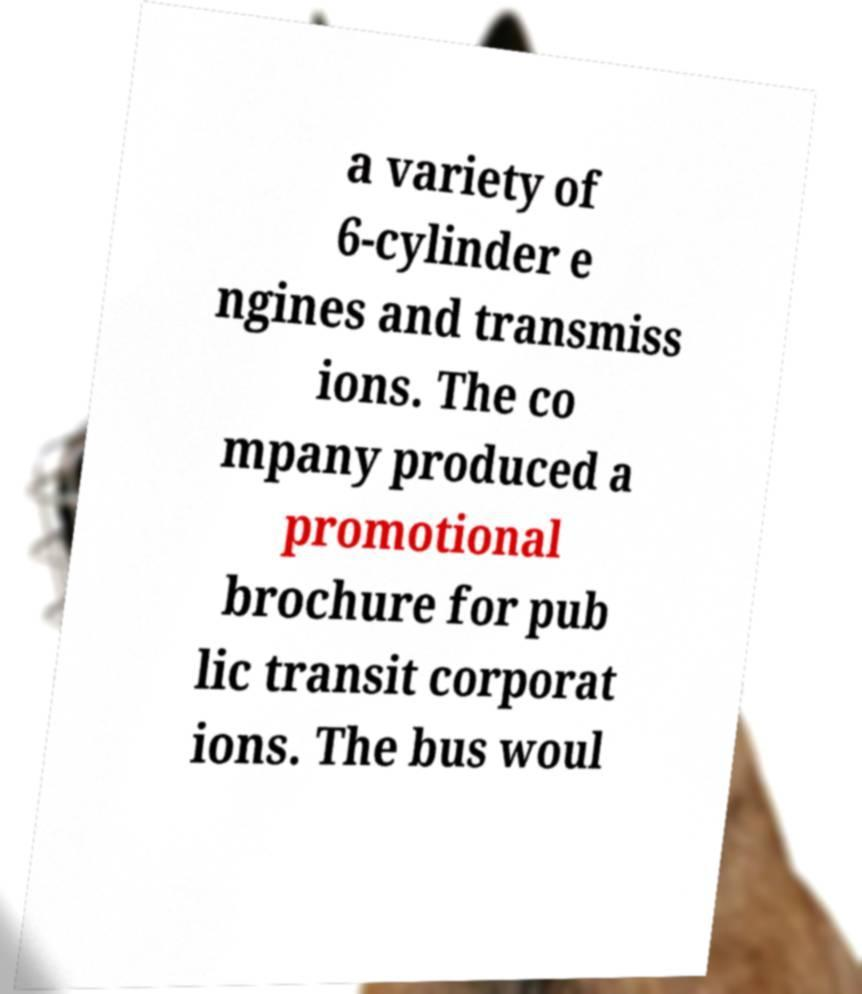Could you assist in decoding the text presented in this image and type it out clearly? a variety of 6-cylinder e ngines and transmiss ions. The co mpany produced a promotional brochure for pub lic transit corporat ions. The bus woul 